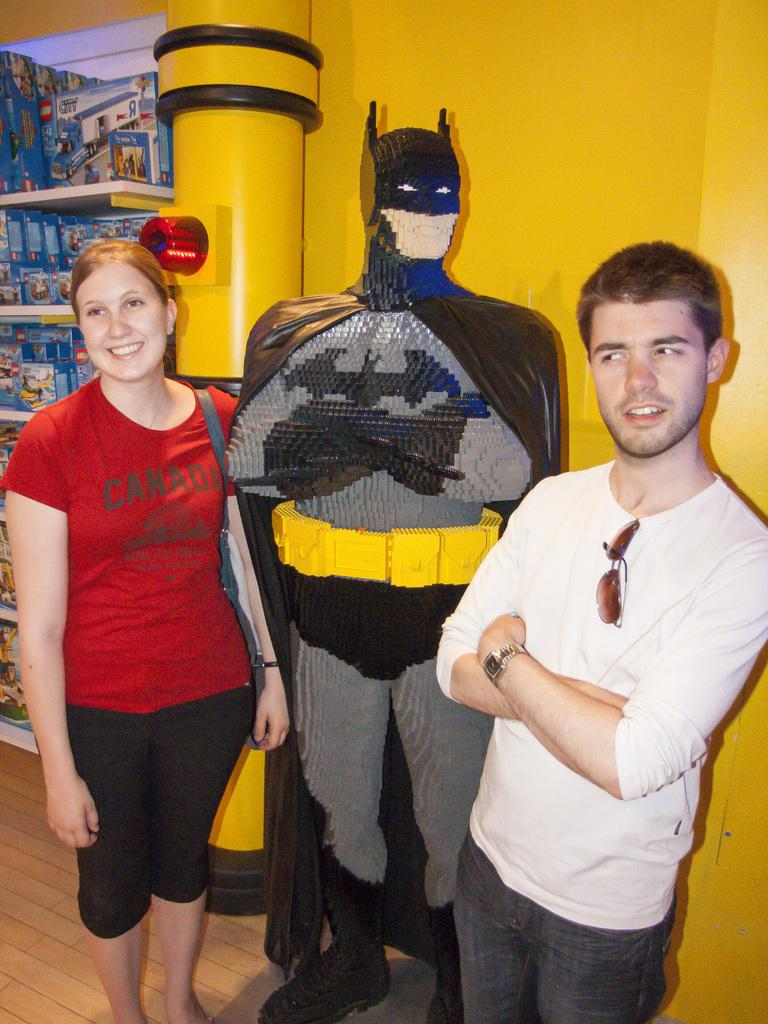How many people are in the image? There are two people in the image, a man and a woman. What are the man and woman doing in the image? The man and woman are standing beside a lego structure. What can be seen in the background of the image? There is a wall in the background of the image, and cartons are placed in a cupboard. What color is the zebra's eye in the image? There is no zebra present in the image, so it is not possible to answer that question. 